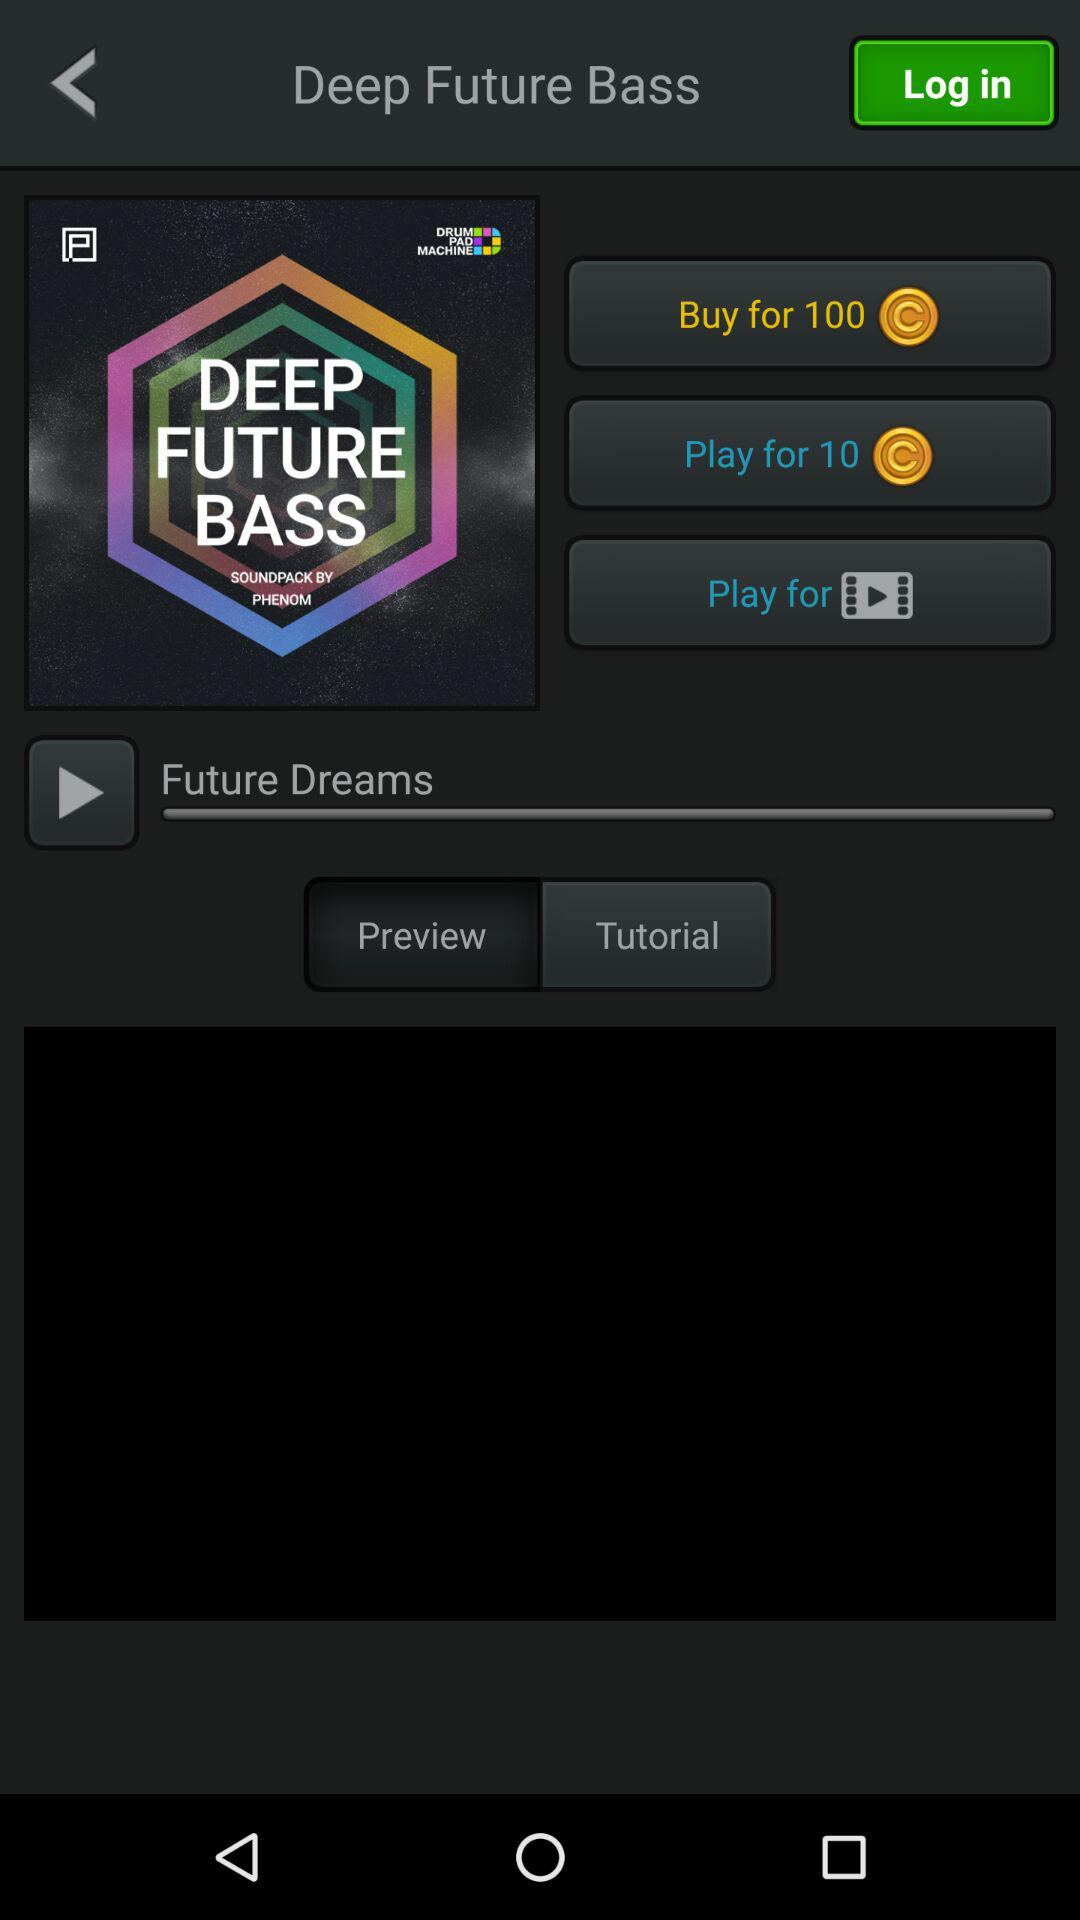What is the price for deep future bass?
When the provided information is insufficient, respond with <no answer>. <no answer> 